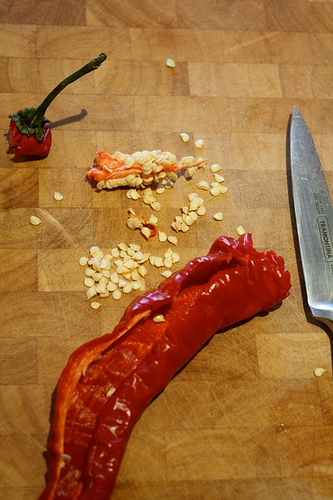<image>
Is the knife behind the chilli? No. The knife is not behind the chilli. From this viewpoint, the knife appears to be positioned elsewhere in the scene. Where is the shadow in relation to the chili? Is it to the right of the chili? Yes. From this viewpoint, the shadow is positioned to the right side relative to the chili. 